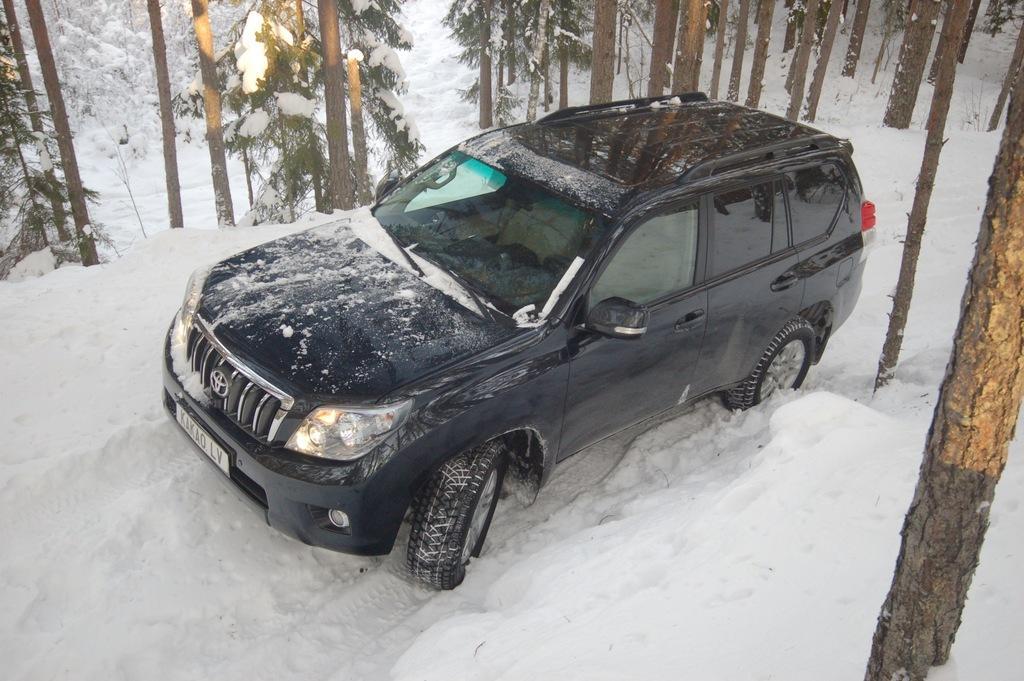Please provide a concise description of this image. In the picture I can see a black color car in the snow and I can see the snow on the car. In the picture I can see the trees. 